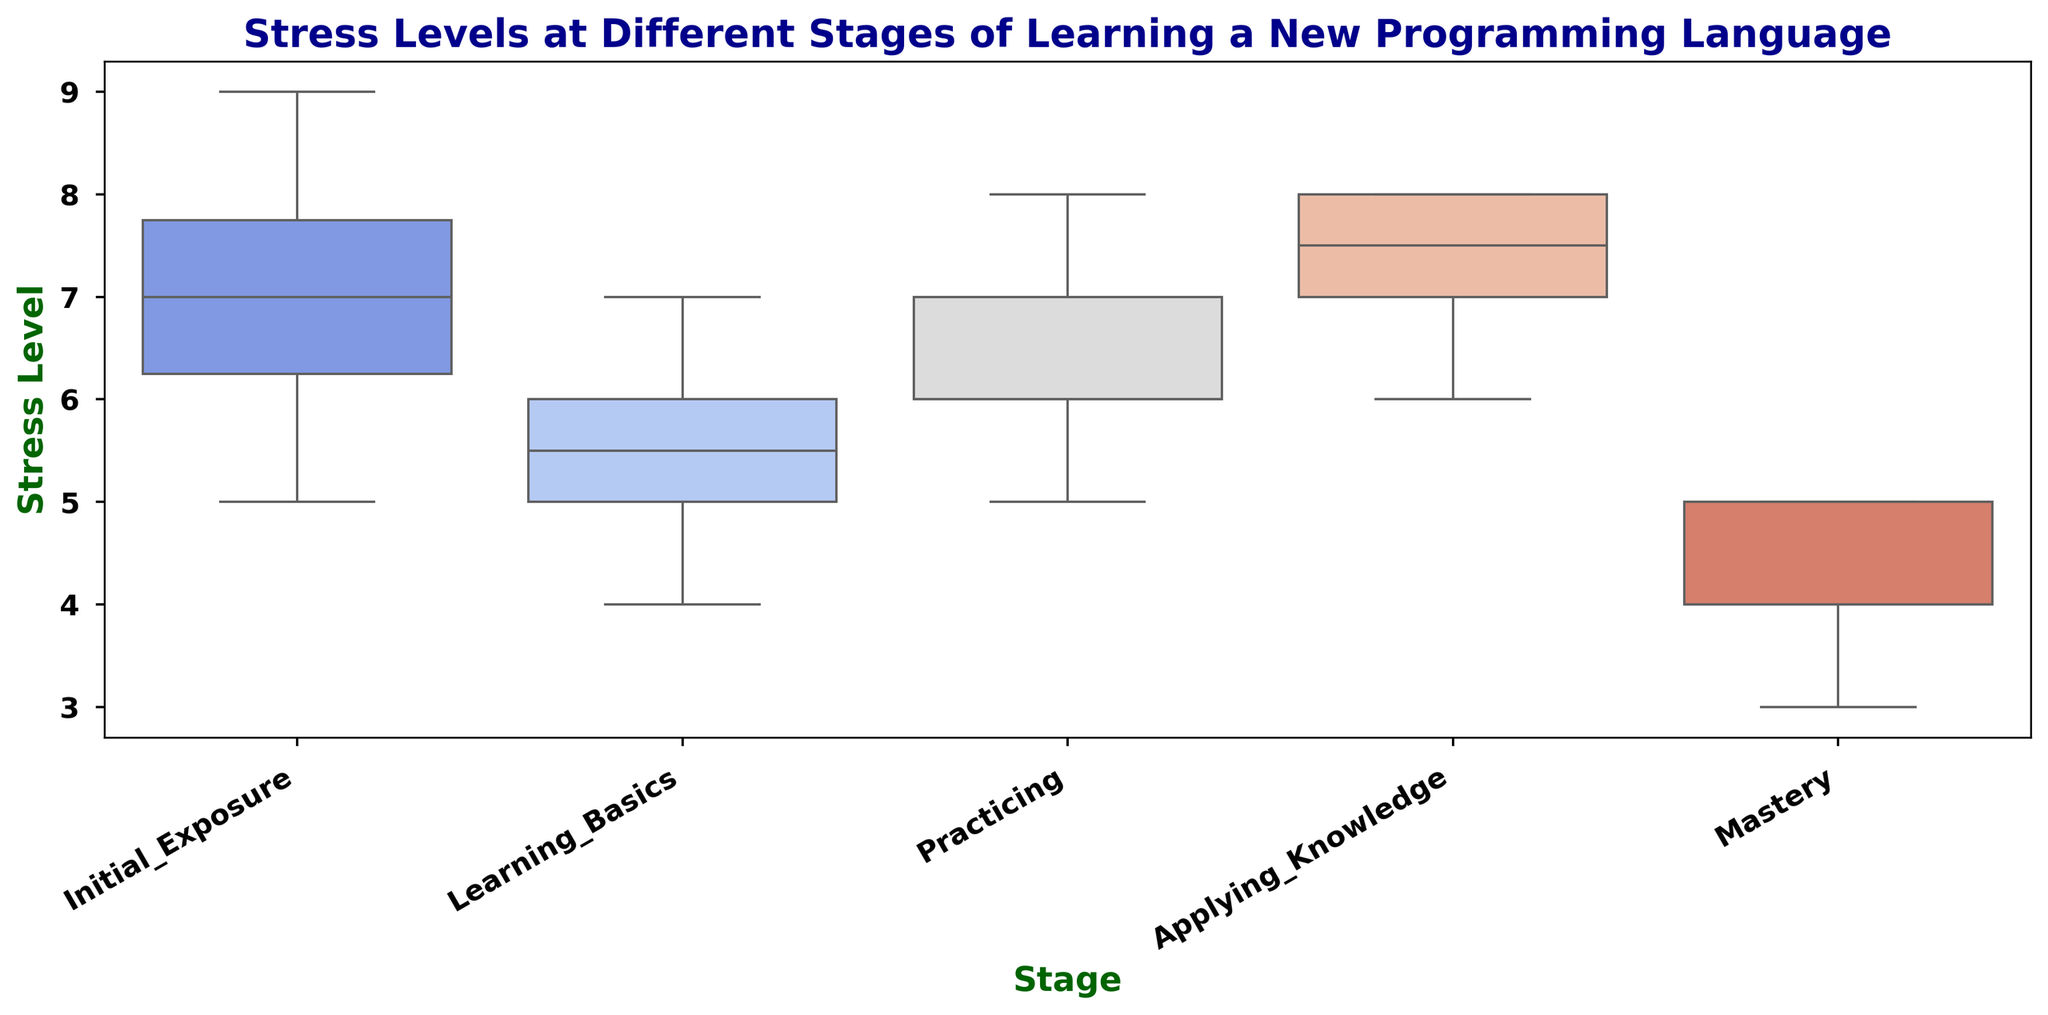Which stage has the highest median stress level? To find the median stress level for each stage, look at the line inside each box of the box plot. The stage "Applying_Knowledge" has the highest median as its line is at level 7.5.
Answer: Applying_Knowledge Which stage has the widest interquartile range (IQR) for stress levels? The interquartile range (IQR) is the range between the first quartile (bottom edge of the box) and third quartile (top edge of the box). "Initial_Exposure" has the widest IQR, as its box is the largest.
Answer: Initial_Exposure Compare the median stress levels between "Learning_Basics" and "Practicing"; which is higher? Look at the median lines (inside the boxes) for both stages. The median stress level for "Practicing" is slightly higher than "Learning_Basics".
Answer: Practicing Which stage has the lowest minimum reported stress level? The minimum reported stress level for each stage is depicted by the bottom whisker. "Mastery" has the lowest minimum stress level, evident from its bottom whisker being at 3.
Answer: Mastery Does the "Practicing" stage have any outliers? Outliers are individual points outside the whiskers. The "Practicing" stage has no points outside the whiskers, so it does not have any outliers.
Answer: No Which stages have the same maximum reported stress level? The maximum stress level for each stage is shown by the top whisker. "Initial_Exposure" and "Applying_Knowledge" both have maximum stress levels of 9 indicated by their top whiskers.
Answer: Initial_Exposure and Applying_Knowledge Is the median stress level of "Mastery" closer to the lower quartile or the upper quartile? The median is the line inside the box. For "Mastery", the median line is closer to the lower quartile (bottom edge of the box) than the upper quartile (top edge of the box).
Answer: Lower quartile How does the variability in stress levels during "Initial_Exposure" compare to "Mastery"? Variability can be inferred from the box and whisker lengths. "Initial_Exposure" has larger spread and greater length in its box and whiskers compared to the more compact distribution of "Mastery."
Answer: More variable Which stage's stress levels are most symmetrically distributed? Symmetry is gauged by the relative position of median and quartiles within the box. "Practicing" has the most symmetric box, where the median line almost divides the box into two equal parts.
Answer: Practicing What is the range of stress levels for the "Learning_Basics" stage? The range is the difference between the maximum and minimum values. For "Learning_Basics," the minimum is 4 and the maximum is 7, so the range is 7 - 4 = 3.
Answer: 3 